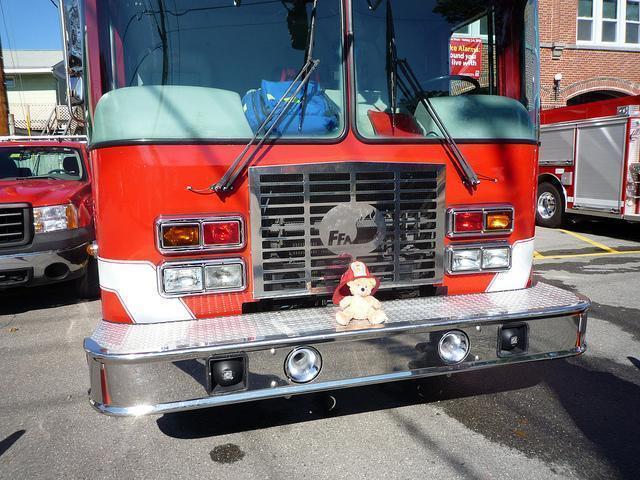How many types of fire engines are available?
Select the accurate answer and provide explanation: 'Answer: answer
Rationale: rationale.'
Options: Four, five, three, two. Answer: four.
Rationale: There are two firetrucks visible. 